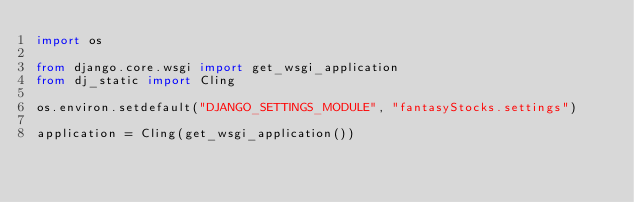<code> <loc_0><loc_0><loc_500><loc_500><_Python_>import os

from django.core.wsgi import get_wsgi_application
from dj_static import Cling

os.environ.setdefault("DJANGO_SETTINGS_MODULE", "fantasyStocks.settings")

application = Cling(get_wsgi_application())
</code> 